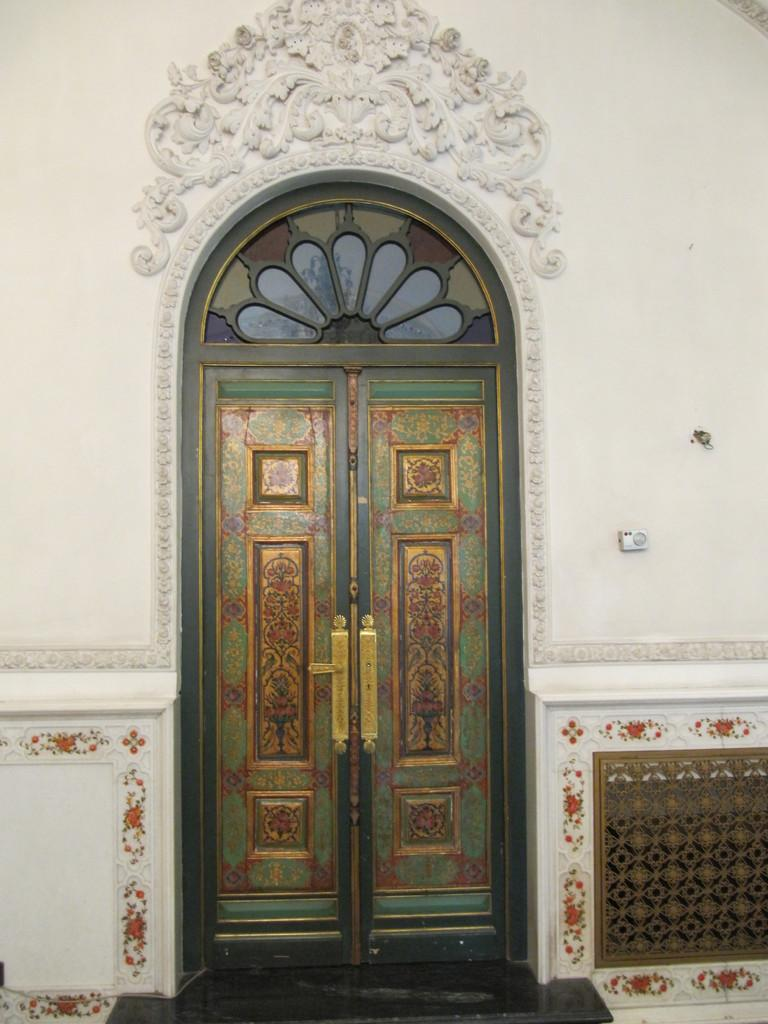What type of structure is visible in the image? There is a building in the image. What feature of the building stands out? The building has colorful doors. What color is the wall that is visible in the image? There is a white wall in the image. Can you tell me where the bird is leading the group in the image? There is no bird or group present in the image; it features a building with colorful doors and a white wall. 